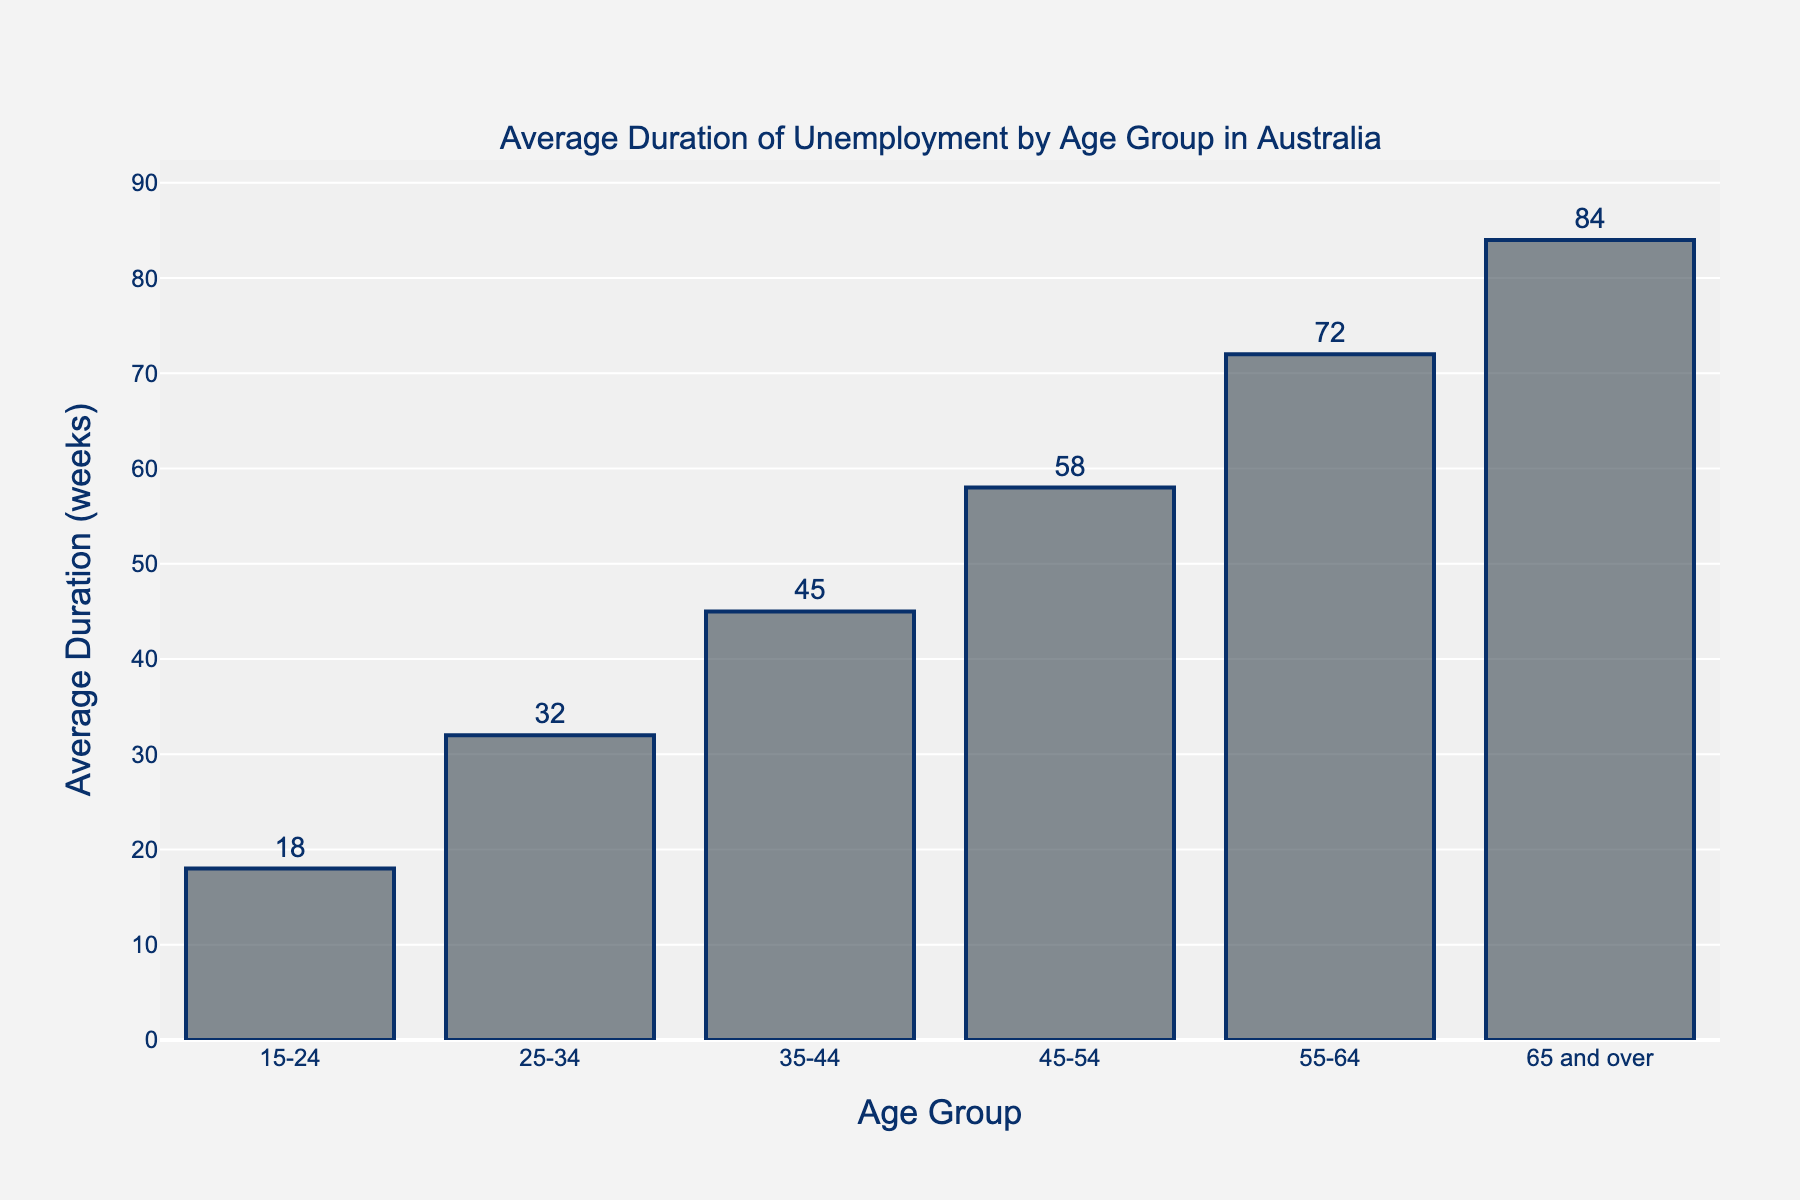Which age group has the longest average duration of unemployment? The bar for the "65 and over" age group is the tallest, indicating it has the longest average duration of unemployment at 84 weeks.
Answer: 65 and over Which age group has the shortest average duration of unemployment? The bar for the "15-24" age group is the smallest, indicating it has the shortest average duration of unemployment at 18 weeks.
Answer: 15-24 What is the difference in average duration of unemployment between the "45-54" and "55-64" age groups? The "45-54" age group's bar shows 58 weeks, and the "55-64" age group's bar shows 72 weeks; the difference is 72 - 58 = 14 weeks.
Answer: 14 weeks By how many weeks does the average duration of unemployment for the "35-44" age group exceed that of the "25-34" age group? The "35-44" age group's bar shows 45 weeks, and the "25-34" age group's bar shows 32 weeks; thus, the "35-44" age group's duration exceeds by 45 - 32 = 13 weeks.
Answer: 13 weeks What is the average duration of unemployment across all age groups? Summing all average durations: 18 + 32 + 45 + 58 + 72 + 84 = 309. There are 6 age groups, so the average is 309 / 6 = 51.5 weeks.
Answer: 51.5 weeks Which age group has an average duration of unemployment closest to the overall average? The calculated overall average is 51.5 weeks. The "45-54" age group has an average of 58 weeks, which is closest to 51.5.
Answer: 45-54 How many weeks is the "55-64" age group above the 30-week mark? The "55-64" age group's bar shows 72 weeks. The amount above 30 weeks is 72 - 30 = 42 weeks.
Answer: 42 weeks Is the average duration of unemployment for the "35-44" age group greater than the overall average? The "35-44" age group's bar shows 45 weeks, and the overall average is 51.5 weeks. Since 45 < 51.5, it is not greater.
Answer: No Which age group represents the median duration of unemployment? Sorting the durations: 18, 32, 45, 58, 72, 84, the median value is the middle one or the average of middle ones (45 and 58). Therefore, the age group is represented by "35-44" and "45-54".
Answer: 35-44, 45-54 